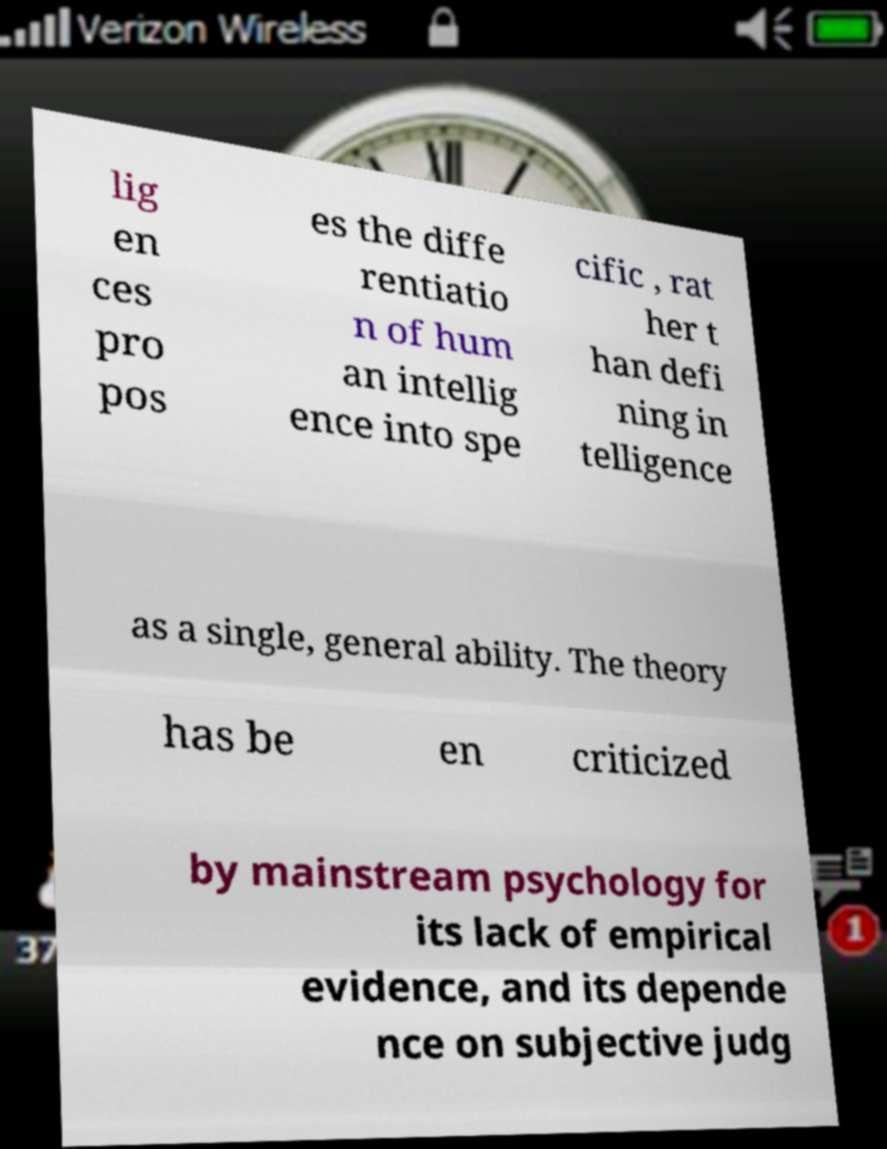Please identify and transcribe the text found in this image. lig en ces pro pos es the diffe rentiatio n of hum an intellig ence into spe cific , rat her t han defi ning in telligence as a single, general ability. The theory has be en criticized by mainstream psychology for its lack of empirical evidence, and its depende nce on subjective judg 